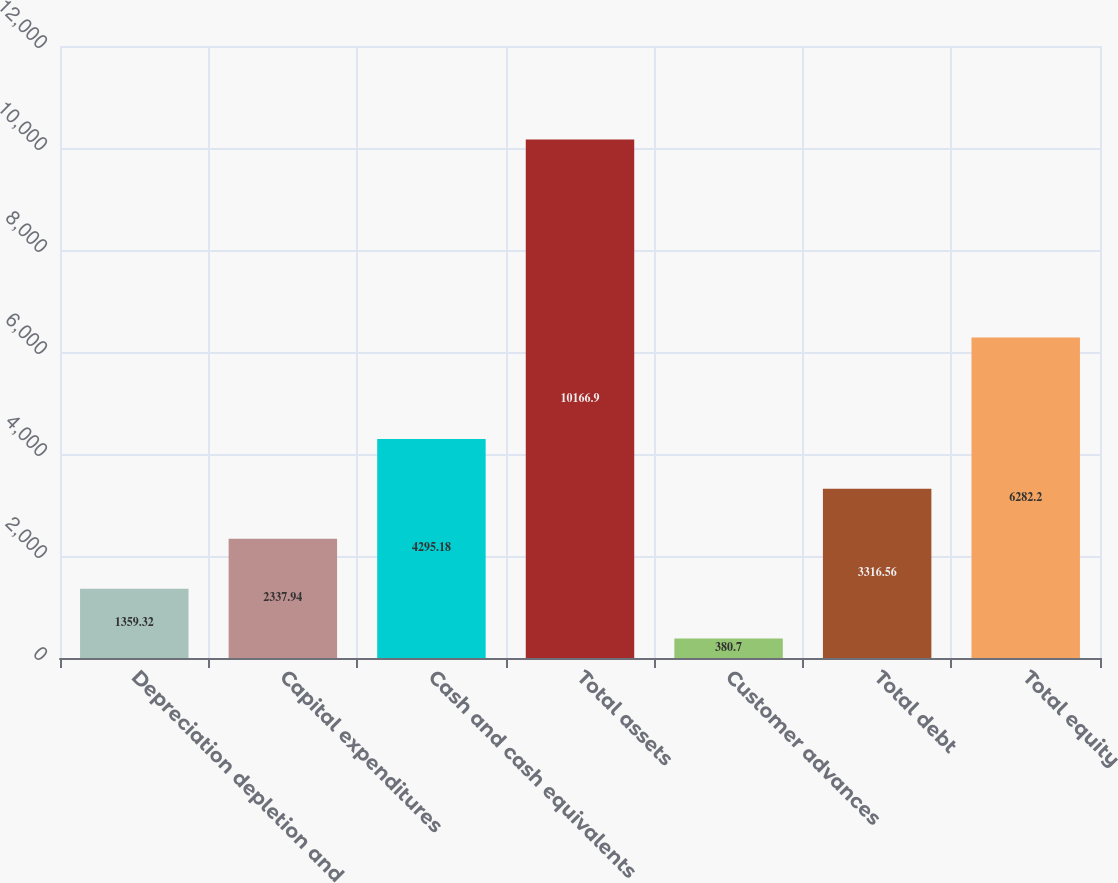Convert chart. <chart><loc_0><loc_0><loc_500><loc_500><bar_chart><fcel>Depreciation depletion and<fcel>Capital expenditures<fcel>Cash and cash equivalents<fcel>Total assets<fcel>Customer advances<fcel>Total debt<fcel>Total equity<nl><fcel>1359.32<fcel>2337.94<fcel>4295.18<fcel>10166.9<fcel>380.7<fcel>3316.56<fcel>6282.2<nl></chart> 